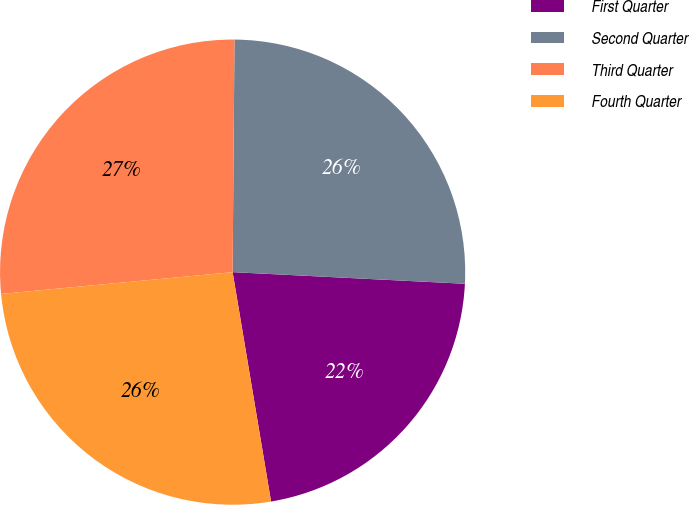Convert chart to OTSL. <chart><loc_0><loc_0><loc_500><loc_500><pie_chart><fcel>First Quarter<fcel>Second Quarter<fcel>Third Quarter<fcel>Fourth Quarter<nl><fcel>21.56%<fcel>25.67%<fcel>26.62%<fcel>26.15%<nl></chart> 